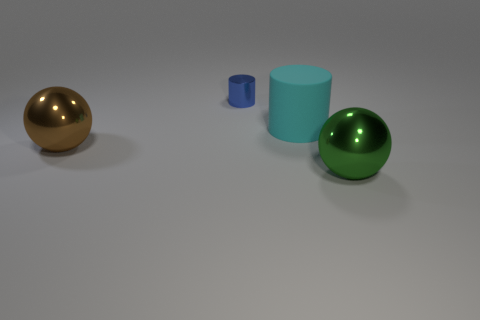Add 4 small gray cylinders. How many objects exist? 8 Add 3 small metallic cylinders. How many small metallic cylinders are left? 4 Add 2 blue cylinders. How many blue cylinders exist? 3 Subtract 0 red cylinders. How many objects are left? 4 Subtract all red rubber objects. Subtract all large cyan matte objects. How many objects are left? 3 